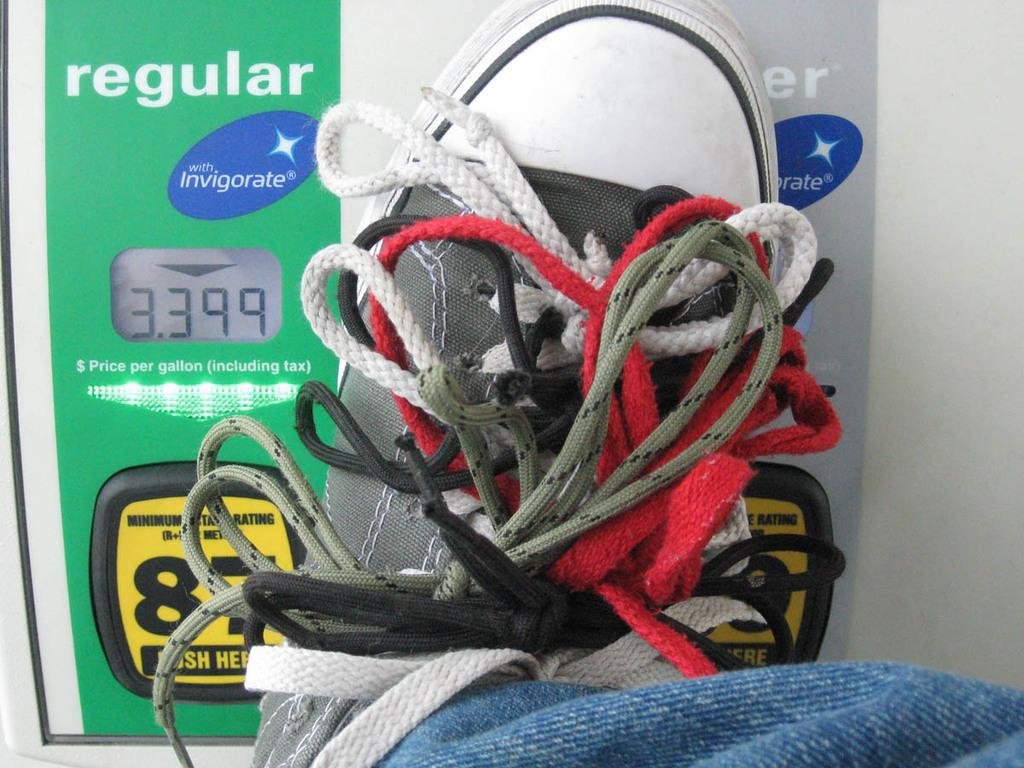What type of footwear is present in the image? There is a shoe in the image. What feature of the shoe is visible in the image? There are shoelaces in the image. What type of plants can be seen growing inside the shoe in the image? There are no plants visible inside the shoe in the image. 